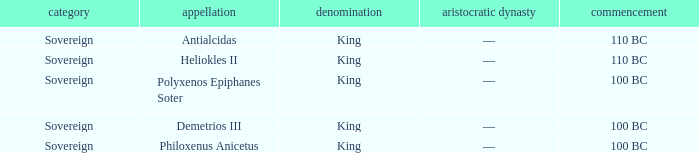When did Philoxenus Anicetus begin to hold power? 100 BC. 